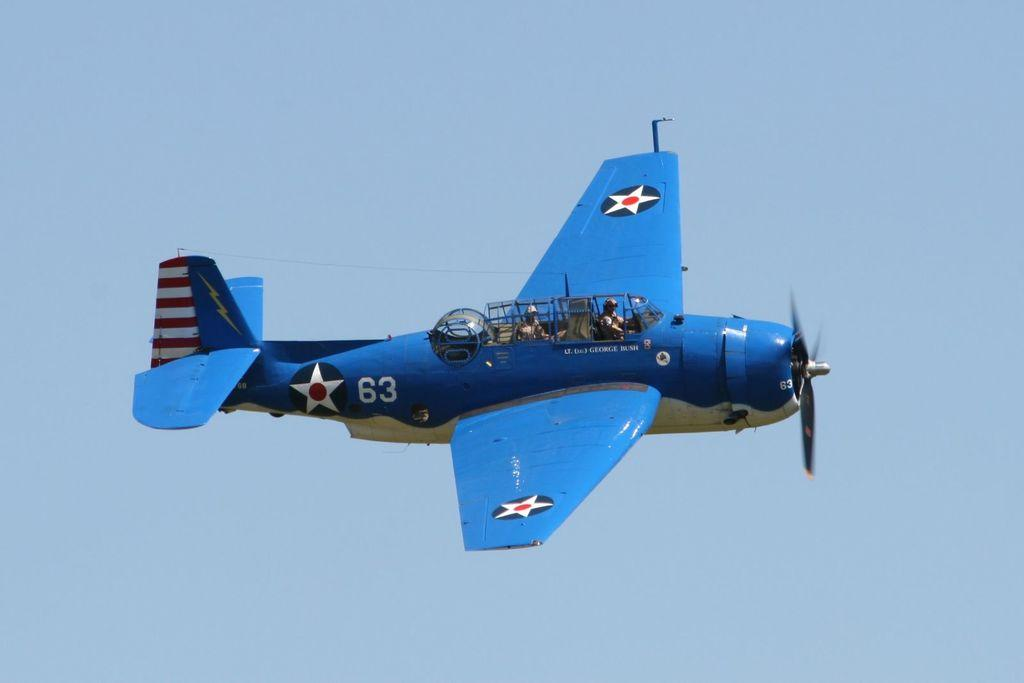What color is the airplane in the image? The airplane in the image is blue. What is the airplane doing in the image? The airplane is flying in the air. What can be seen behind the airplane in the image? The sky is visible behind the airplane. What type of silk is being used to create the airplane's wings in the image? There is no silk mentioned or visible in the image; the airplane's wings are not made of silk. 